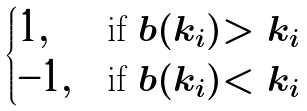<formula> <loc_0><loc_0><loc_500><loc_500>\begin{cases} 1 , & \text {if } b ( k _ { i } ) > k _ { i } \\ - 1 , & \text {if } b ( k _ { i } ) < k _ { i } \end{cases}</formula> 